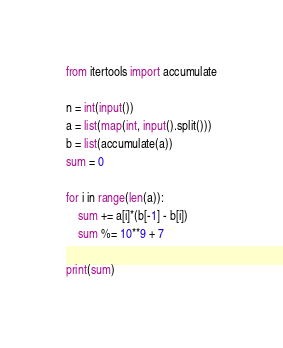Convert code to text. <code><loc_0><loc_0><loc_500><loc_500><_Python_>from itertools import accumulate

n = int(input())
a = list(map(int, input().split()))
b = list(accumulate(a))
sum = 0

for i in range(len(a)):
    sum += a[i]*(b[-1] - b[i])
    sum %= 10**9 + 7

print(sum)
</code> 